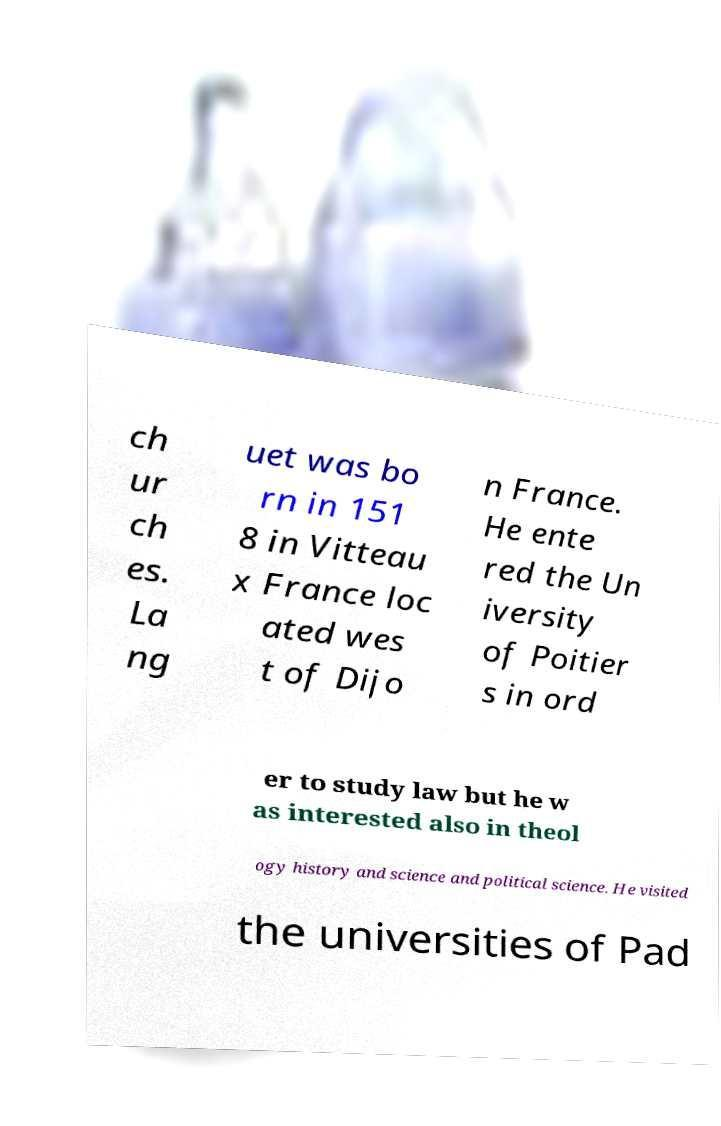Could you extract and type out the text from this image? ch ur ch es. La ng uet was bo rn in 151 8 in Vitteau x France loc ated wes t of Dijo n France. He ente red the Un iversity of Poitier s in ord er to study law but he w as interested also in theol ogy history and science and political science. He visited the universities of Pad 